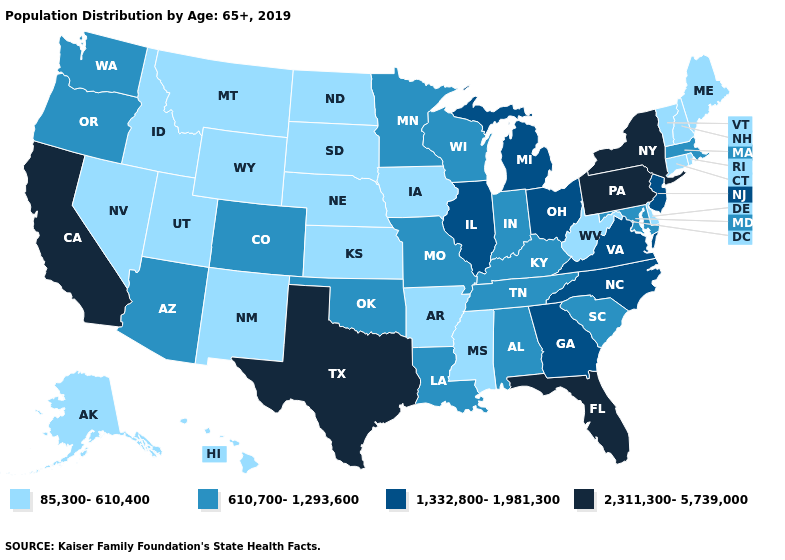What is the value of Montana?
Give a very brief answer. 85,300-610,400. What is the value of Utah?
Be succinct. 85,300-610,400. What is the lowest value in the USA?
Be succinct. 85,300-610,400. Does Georgia have the same value as Virginia?
Concise answer only. Yes. Does Alabama have the lowest value in the USA?
Give a very brief answer. No. What is the highest value in the West ?
Quick response, please. 2,311,300-5,739,000. What is the lowest value in the West?
Keep it brief. 85,300-610,400. Among the states that border New Jersey , which have the lowest value?
Concise answer only. Delaware. Which states have the lowest value in the USA?
Be succinct. Alaska, Arkansas, Connecticut, Delaware, Hawaii, Idaho, Iowa, Kansas, Maine, Mississippi, Montana, Nebraska, Nevada, New Hampshire, New Mexico, North Dakota, Rhode Island, South Dakota, Utah, Vermont, West Virginia, Wyoming. Which states hav the highest value in the South?
Give a very brief answer. Florida, Texas. What is the value of Iowa?
Keep it brief. 85,300-610,400. What is the highest value in the South ?
Concise answer only. 2,311,300-5,739,000. Name the states that have a value in the range 85,300-610,400?
Answer briefly. Alaska, Arkansas, Connecticut, Delaware, Hawaii, Idaho, Iowa, Kansas, Maine, Mississippi, Montana, Nebraska, Nevada, New Hampshire, New Mexico, North Dakota, Rhode Island, South Dakota, Utah, Vermont, West Virginia, Wyoming. Does Texas have a lower value than Michigan?
Quick response, please. No. Does Connecticut have the lowest value in the Northeast?
Be succinct. Yes. 